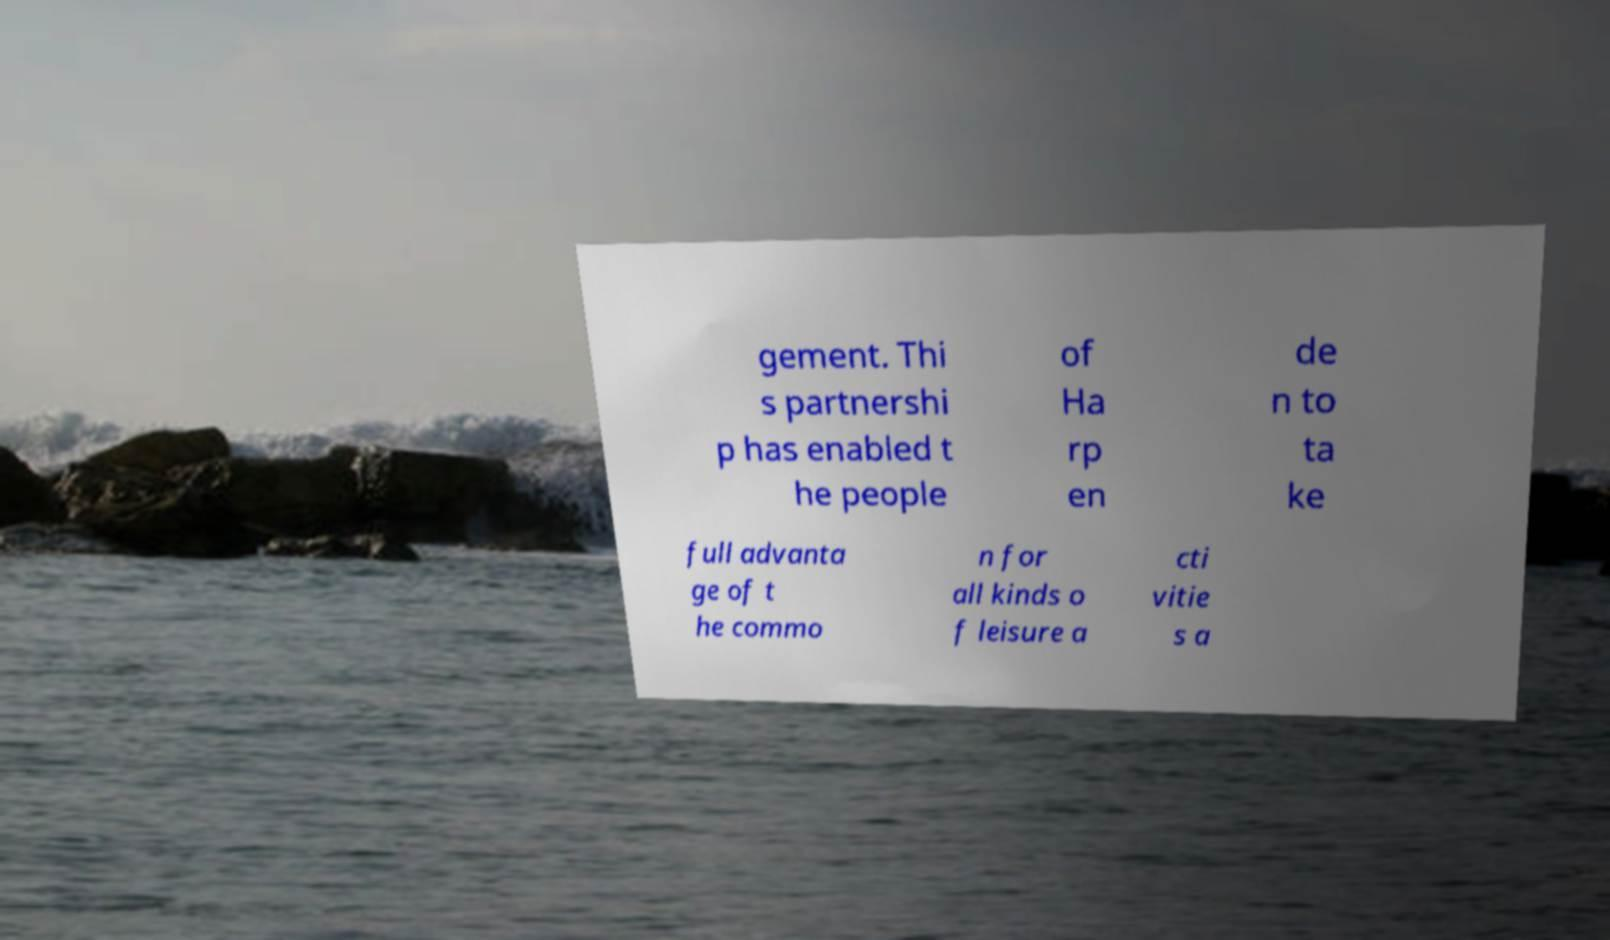Could you extract and type out the text from this image? gement. Thi s partnershi p has enabled t he people of Ha rp en de n to ta ke full advanta ge of t he commo n for all kinds o f leisure a cti vitie s a 